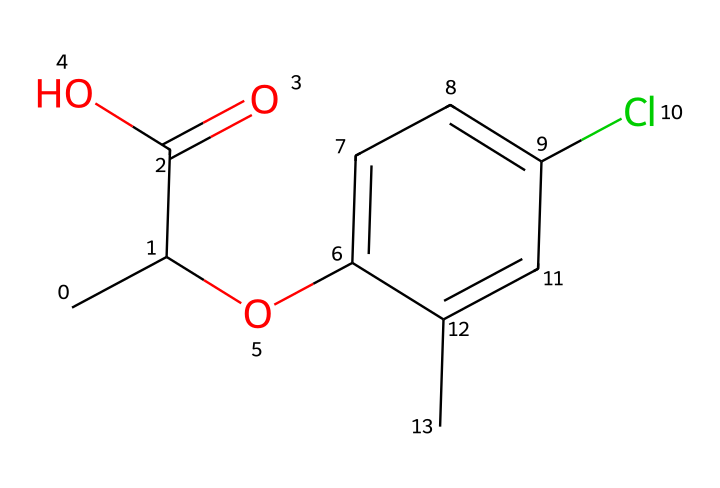What is the name of this herbicide? The SMILES representation corresponds to the chemical structure of mecoprop. The specific arrangement of atoms suggests it is a selective herbicide used primarily on lawns and turf areas.
Answer: mecoprop How many carbon atoms are present in this molecule? By analyzing the SMILES notation, we count the number of "C" characters. This representation has a total of 10 carbon atoms present in the structure.
Answer: 10 What is the function of the carboxylic acid group in this herbicide? The carboxylic acid group (C(=O)O) contributes to the herbicide's ability to disrupt plant growth by interfering with hormonal functions in plants. This functionality is crucial for SELECTIVE control in turf areas.
Answer: disrupt plant growth How many chlorine atoms are there in the structure? In the given SMILES representation, we identify a chlorine atom represented by "Cl." There is only one chlorine atom in this chemical structure.
Answer: 1 What effect does the presence of the chlorine atom have on herbicide activity? The chlorine atom increases herbicidal activity by enhancing the lipophilicity of the molecule, thereby improving its ability to penetrate plant tissues. This property is important for its effectiveness in targeting unwanted plants while preserving desired turf.
Answer: enhance activity What is the significance of the ester functional group in this herbicide? The ester group (Oc) is important in providing selectivity and stability of the herbicide. It allows for proper interaction with plant receptors while reducing volatility, which helps control unwanted weed species.
Answer: selectivity and stability How does this herbicide affect grassy weeds compared to broadleaf weeds? Mecoprop is designed to selectively control broadleaf weeds without harming grassy areas. This selectivity is attributed to its unique molecular structure, which interacts differently with the hormonal pathways in these two types of plants.
Answer: selectively controls broadleaf weeds 